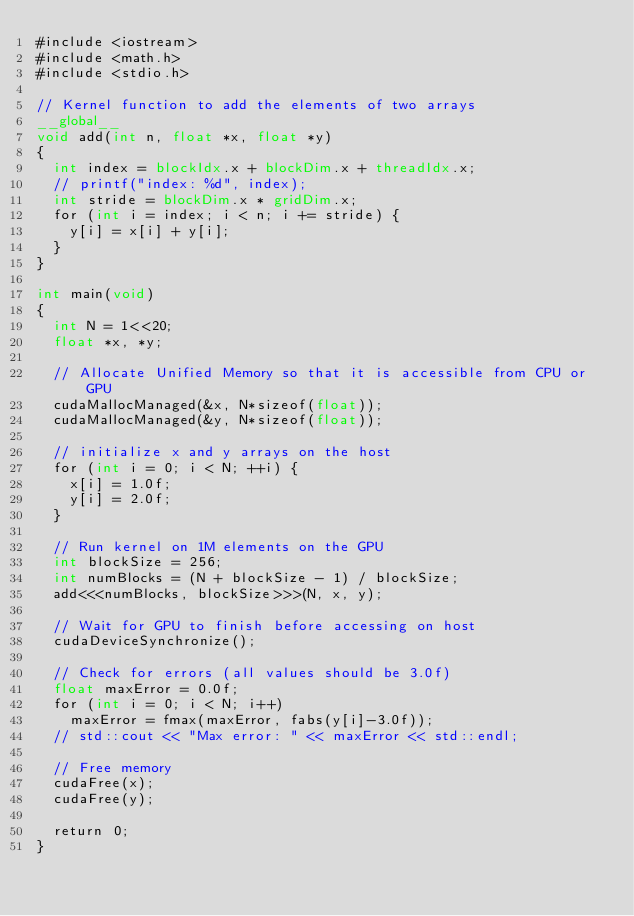Convert code to text. <code><loc_0><loc_0><loc_500><loc_500><_Cuda_>#include <iostream>
#include <math.h>
#include <stdio.h>

// Kernel function to add the elements of two arrays
__global__
void add(int n, float *x, float *y)
{
  int index = blockIdx.x + blockDim.x + threadIdx.x;
  // printf("index: %d", index);
  int stride = blockDim.x * gridDim.x;
  for (int i = index; i < n; i += stride) {
    y[i] = x[i] + y[i];
  }
}

int main(void)
{
  int N = 1<<20;
  float *x, *y;

  // Allocate Unified Memory so that it is accessible from CPU or GPU
  cudaMallocManaged(&x, N*sizeof(float));
  cudaMallocManaged(&y, N*sizeof(float));

  // initialize x and y arrays on the host
  for (int i = 0; i < N; ++i) {
    x[i] = 1.0f;
    y[i] = 2.0f;
  }

  // Run kernel on 1M elements on the GPU
  int blockSize = 256;
  int numBlocks = (N + blockSize - 1) / blockSize;
  add<<<numBlocks, blockSize>>>(N, x, y);

  // Wait for GPU to finish before accessing on host
  cudaDeviceSynchronize();

  // Check for errors (all values should be 3.0f)
  float maxError = 0.0f;
  for (int i = 0; i < N; i++)
    maxError = fmax(maxError, fabs(y[i]-3.0f));
  // std::cout << "Max error: " << maxError << std::endl;

  // Free memory
  cudaFree(x);
  cudaFree(y);

  return 0;
}
</code> 